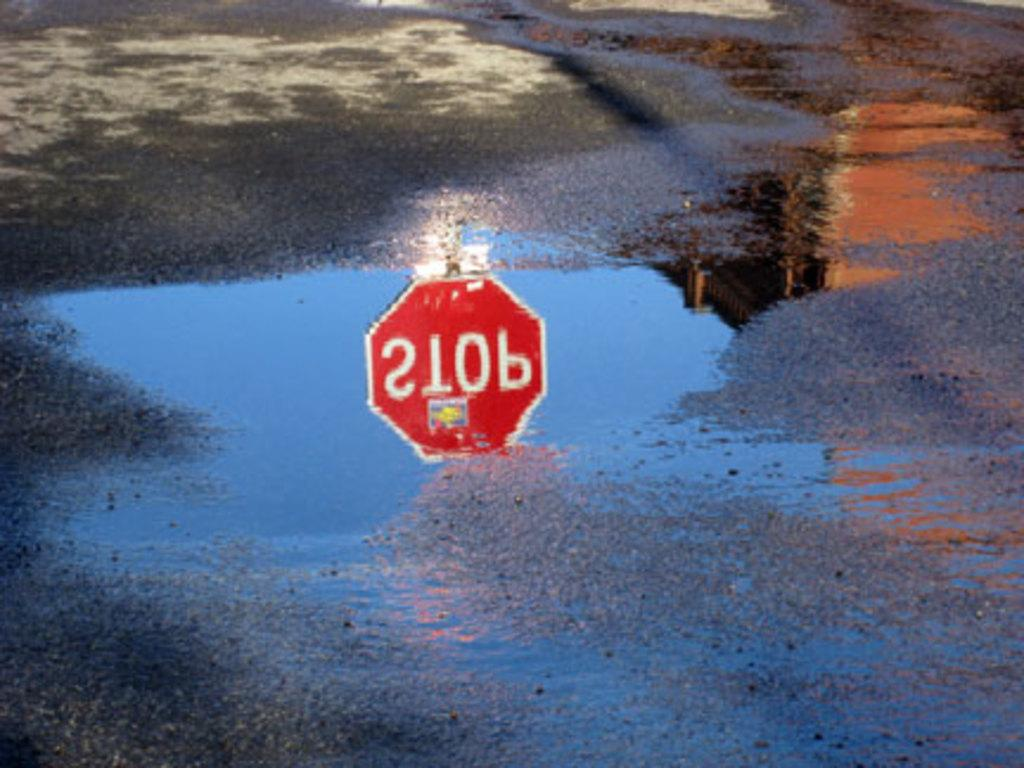<image>
Render a clear and concise summary of the photo. A stop sign image is reflected in a puddle in the road. 